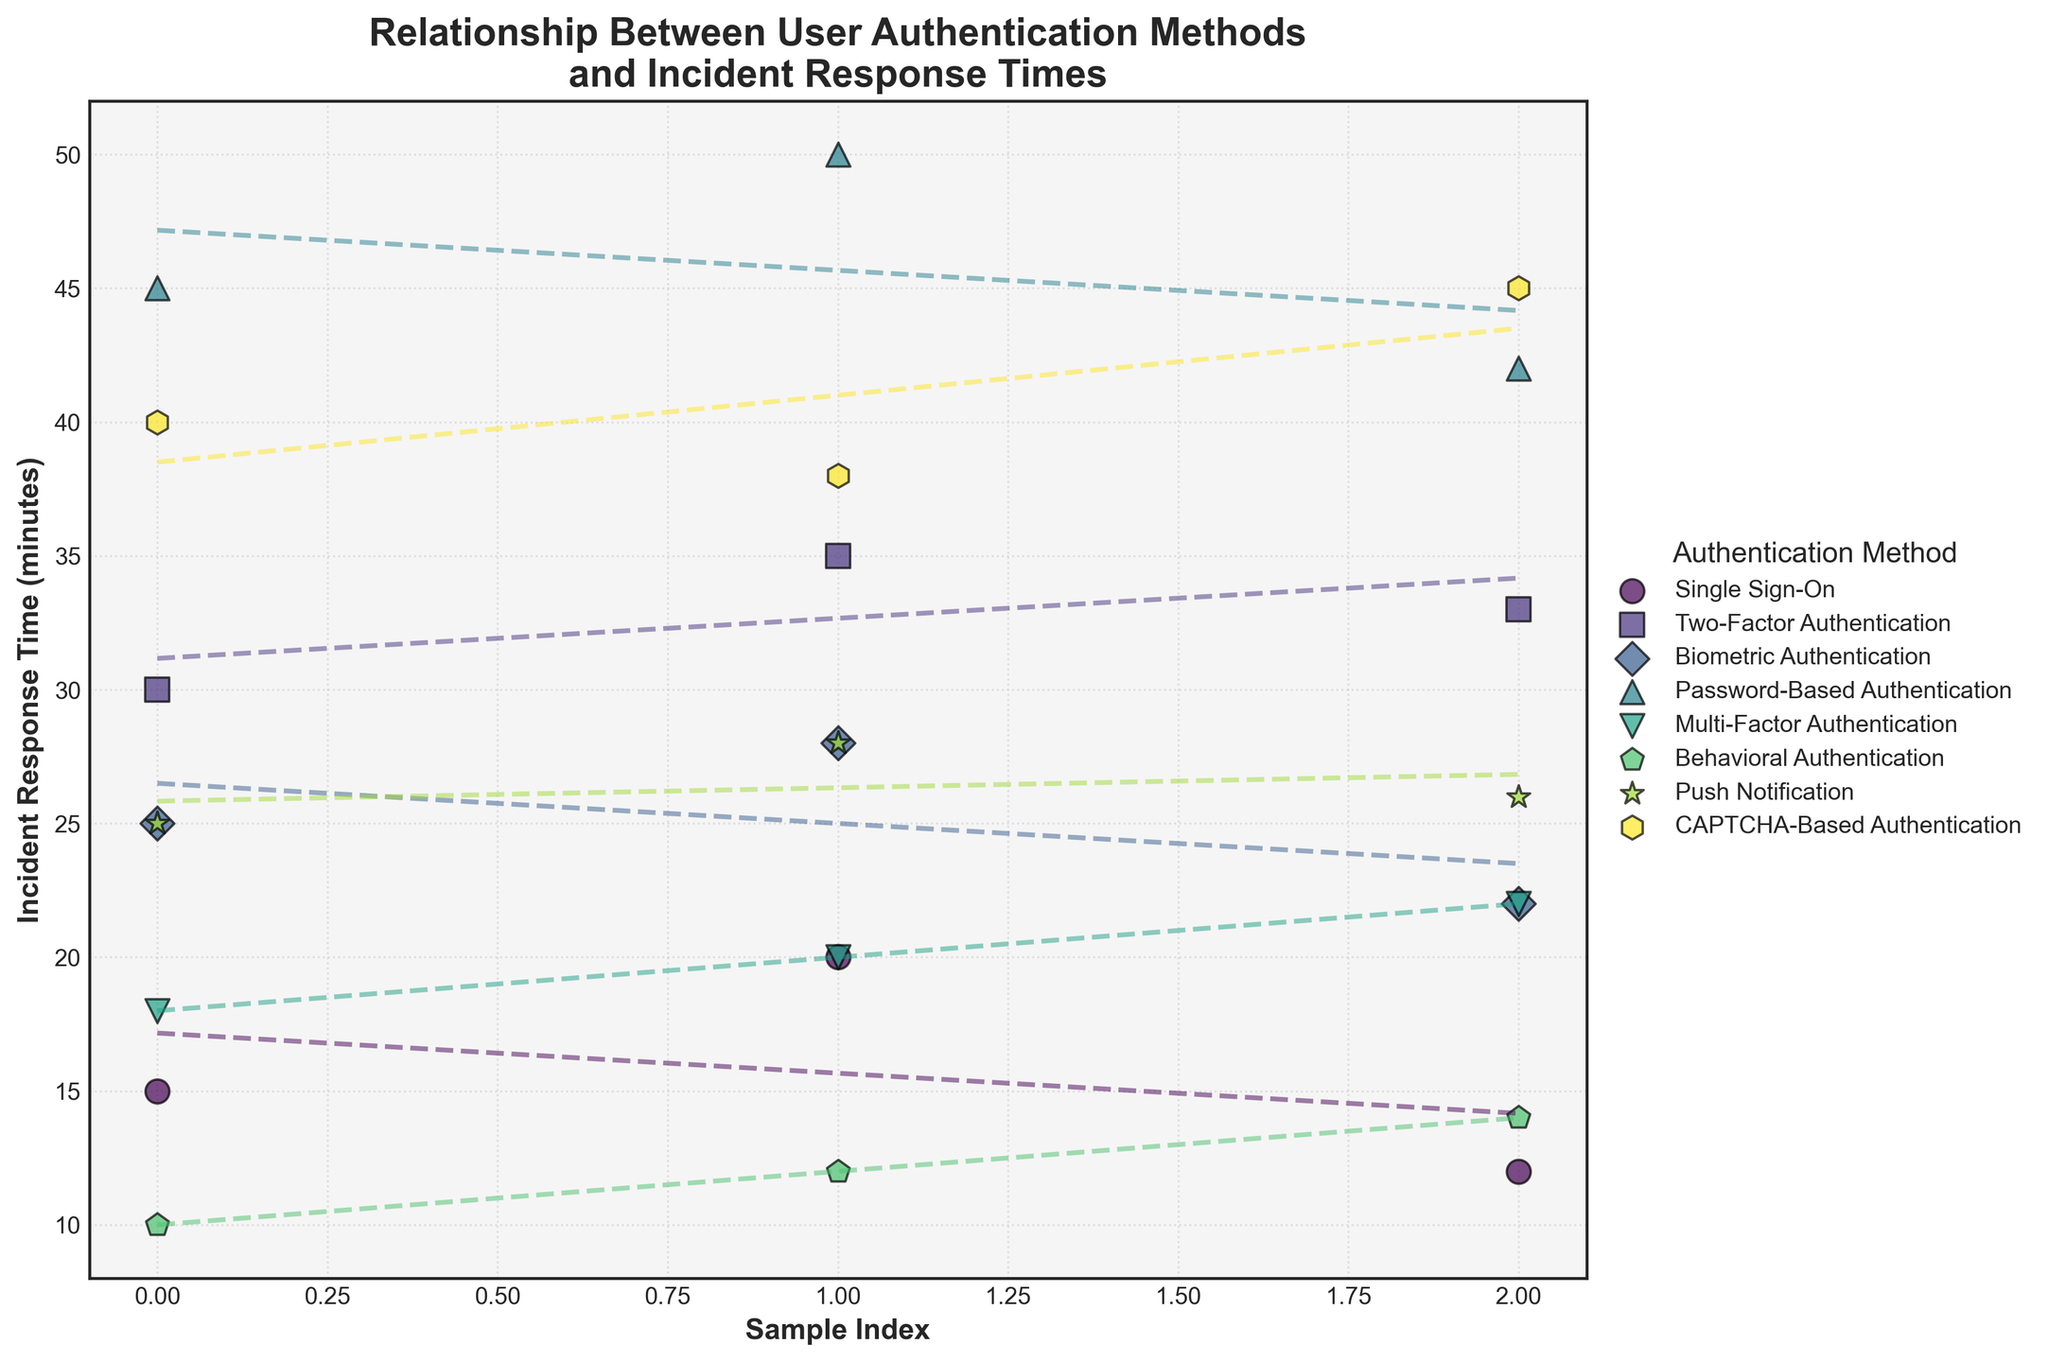Which User Authentication Method has the highest average incident response time? To find the highest average response time, identify the response times for each method and calculate their averages. Password-Based Authentication has the highest average response time at approximately 45.67 minutes.
Answer: Password-Based Authentication Which User Authentication Method shows the steepest trend line increasing over the sample index? The steepness of the trend line is determined by the slope of the line. Two-Factor Authentication has the steepest increasing trend line.
Answer: Two-Factor Authentication How many sample points are there for the Biometric Authentication method? Count the number of data points on the plot corresponding to the Biometric Authentication method. There are 3 sample points for Biometric Authentication.
Answer: 3 Which User Authentication Method has the least variation in incident response times? Variation is indicated by the spread of data points. Behavioral Authentication has the least variation as its data points are closer to each other.
Answer: Behavioral Authentication How does the average incident response time of Two-Factor Authentication compare to that of CAPTCHA-Based Authentication? Calculate the averages: Two-Factor Authentication (32.67 minutes) vs. CAPTCHA-Based Authentication (41 minutes). Two-Factor Authentication's average is lower.
Answer: Two-Factor Authentication is lower How many different User Authentication Methods are compared in the plot? Count the number of unique methods indicated by the legend. There are 8 different User Authentication Methods.
Answer: 8 Which User Authentication Method has the trend line with the lowest slope? Identify the trend line with the least steep slope; Single Sign-On has the lowest slope trend line.
Answer: Single Sign-On What’s the incident response time range for Multi-Factor Authentication? Identify the minimum and maximum data points for Multi-Factor Authentication; the range is from 18 to 22 minutes.
Answer: 18 to 22 minutes How does the variation in incident response times for Push Notification compare to Biometric Authentication? Compare the spread of data points for both methods. Push Notification shows a slightly higher variation than Biometric Authentication.
Answer: Push Notification has higher variation What is the maximum incident response time recorded, and which User Authentication Method does it belong to? Identify the highest data point on the plot. The maximum incident response time is 50 minutes for Password-Based Authentication.
Answer: 50 minutes, Password-Based Authentication 